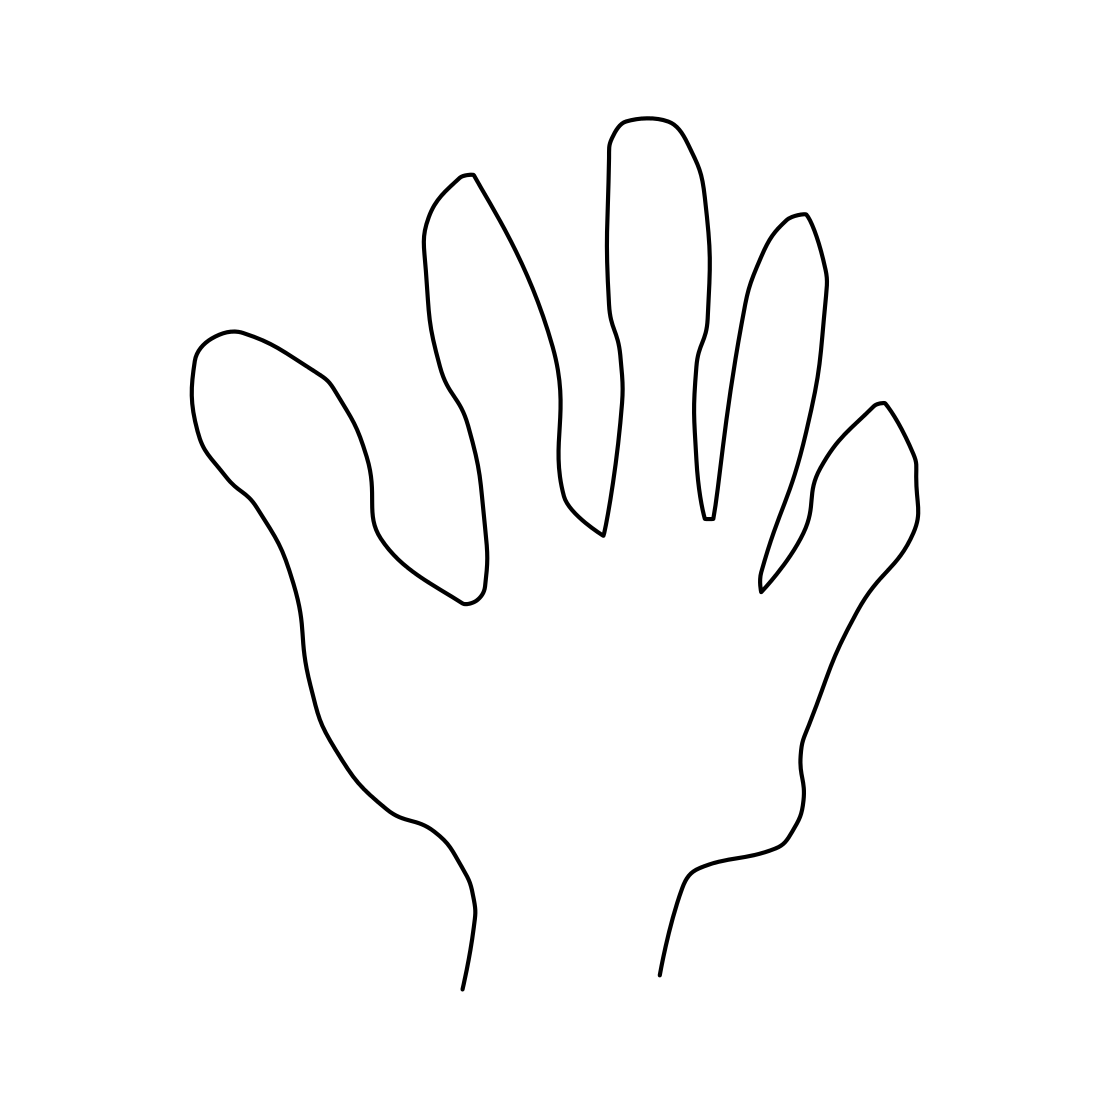Can you explain what this drawing might be used for? The image appears to be a minimalistic line drawing of a human hand. Such drawings are often used for educational purposes, artistic reference, or in various design fields to represent the human form in a simplified manner. It could be part of a learning material on human anatomy or an icon in graphic design. 